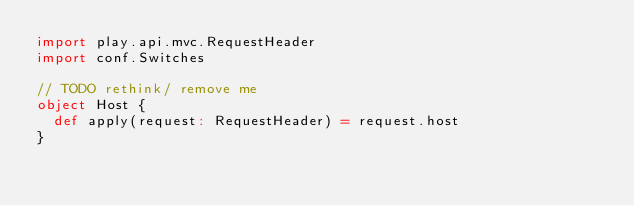Convert code to text. <code><loc_0><loc_0><loc_500><loc_500><_Scala_>import play.api.mvc.RequestHeader
import conf.Switches

// TODO rethink/ remove me
object Host {
  def apply(request: RequestHeader) = request.host
}
</code> 